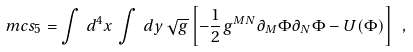Convert formula to latex. <formula><loc_0><loc_0><loc_500><loc_500>\ m c s _ { 5 } = \int \, d ^ { 4 } x \, \int \, d y \, \sqrt { g } \left [ - \frac { 1 } { 2 } g ^ { M N } \partial _ { M } \Phi \partial _ { N } \Phi - U ( \Phi ) \right ] \ ,</formula> 